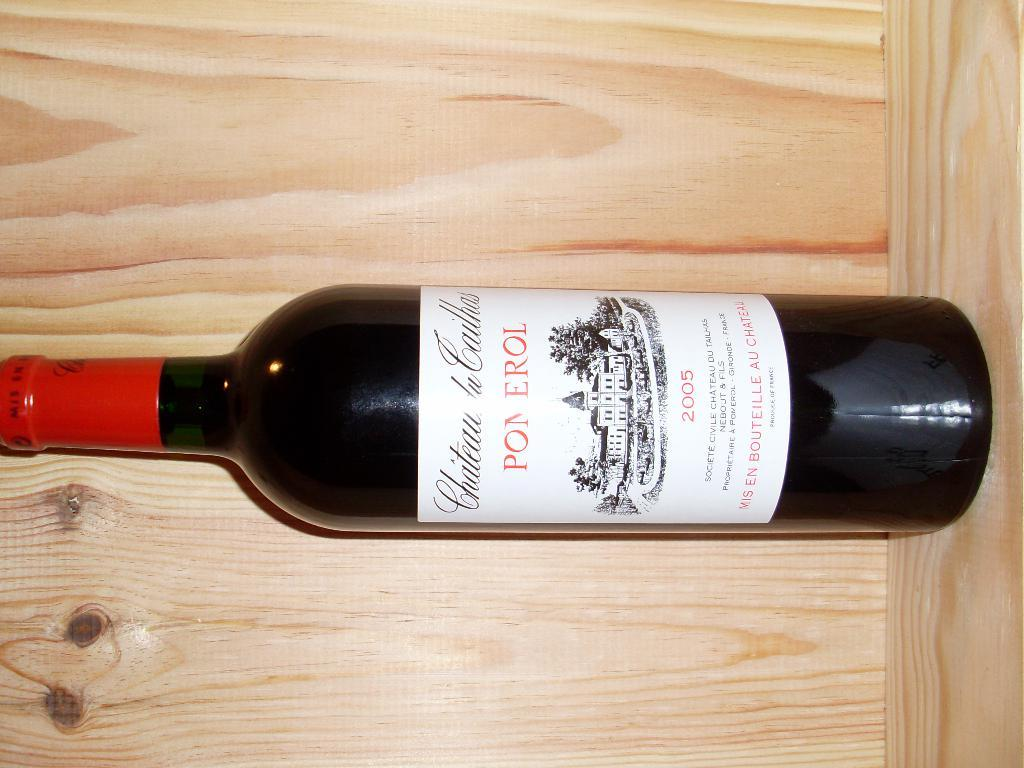<image>
Write a terse but informative summary of the picture. A bottle of vintage 2005 Pomerol wine sits on a pine shelf. 